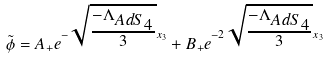Convert formula to latex. <formula><loc_0><loc_0><loc_500><loc_500>\tilde { \phi } = A _ { + } e ^ { - \sqrt { \frac { - \Lambda _ { A d S _ { 4 } } } { 3 } } x _ { 3 } } + B _ { + } e ^ { - 2 \sqrt { \frac { - \Lambda _ { A d S _ { 4 } } } { 3 } } x _ { 3 } }</formula> 